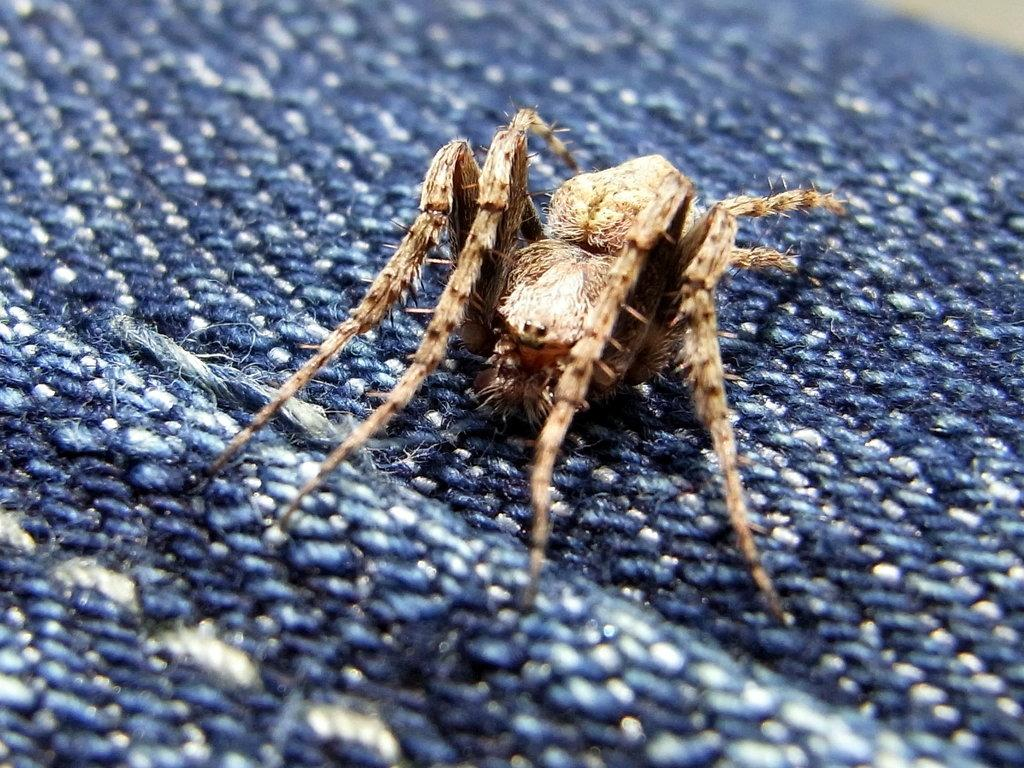What type of creature is present in the image? There is an insect in the image. Where is the insect located in the image? The insect is on a surface. What type of yarn is the insect using to create a memory in the image? There is no yarn or memory creation activity involving the insect in the image. 